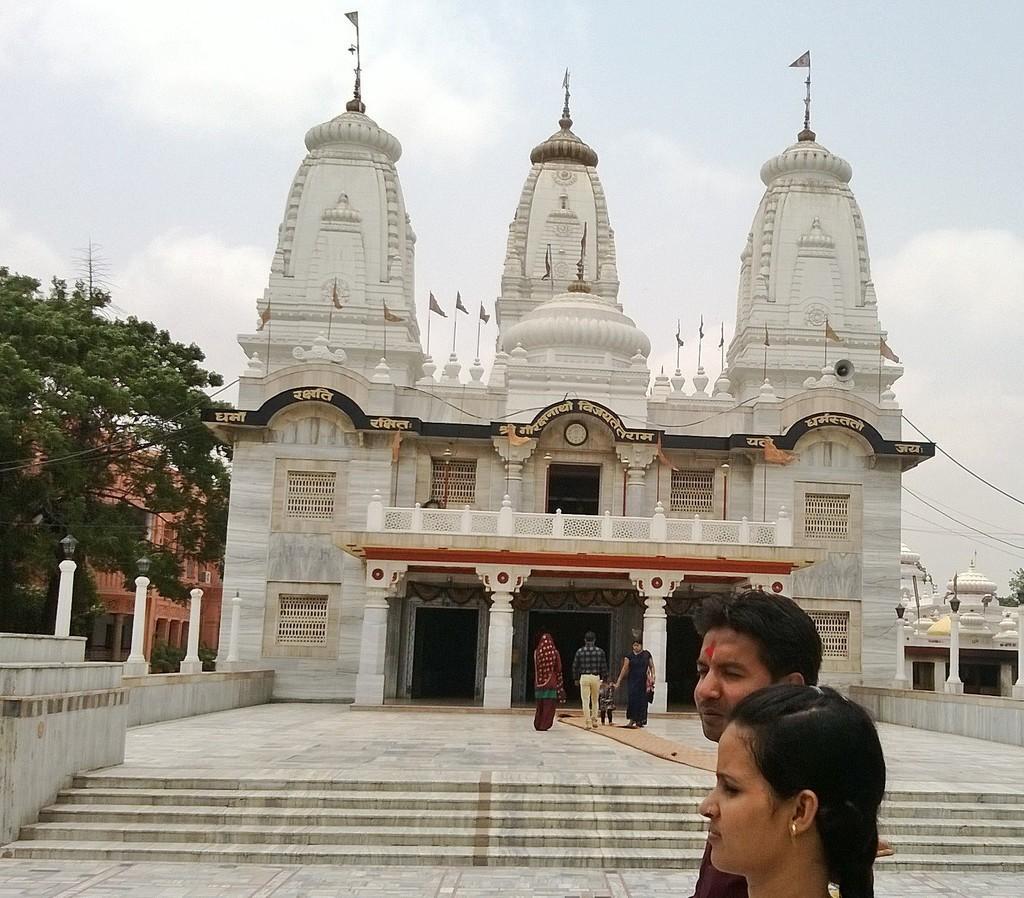Please provide a concise description of this image. In the picture I can see a temple and buildings. I can also see steps, people are standing on the ground, trees, flags on the temple and wires. In the background I can see the sky. 